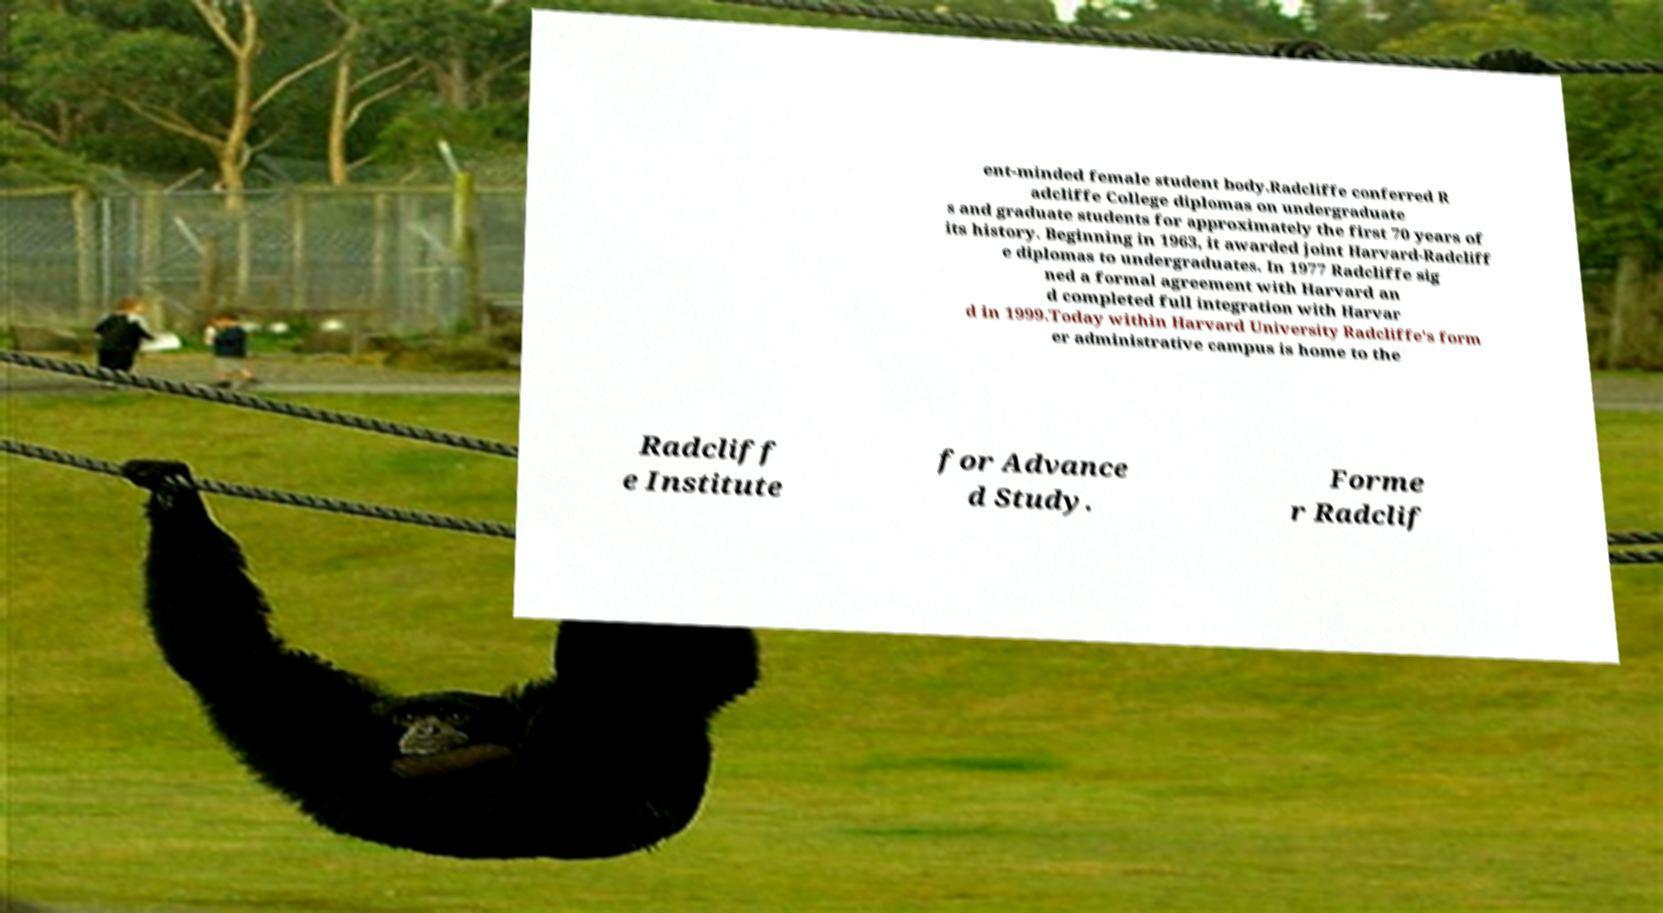Can you accurately transcribe the text from the provided image for me? ent-minded female student body.Radcliffe conferred R adcliffe College diplomas on undergraduate s and graduate students for approximately the first 70 years of its history. Beginning in 1963, it awarded joint Harvard-Radcliff e diplomas to undergraduates. In 1977 Radcliffe sig ned a formal agreement with Harvard an d completed full integration with Harvar d in 1999.Today within Harvard University Radcliffe's form er administrative campus is home to the Radcliff e Institute for Advance d Study. Forme r Radclif 